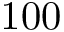<formula> <loc_0><loc_0><loc_500><loc_500>1 0 0</formula> 